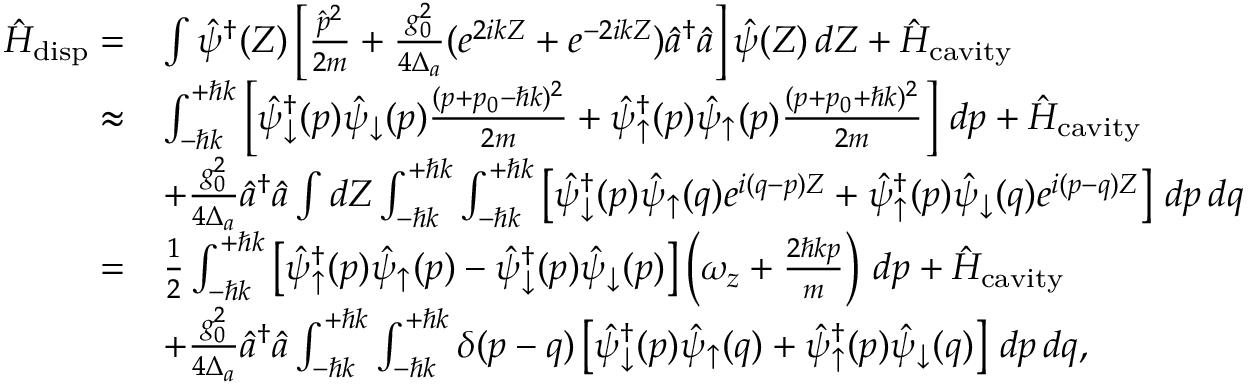<formula> <loc_0><loc_0><loc_500><loc_500>\begin{array} { r l } { \hat { H } _ { d i s p } = } & { \int \hat { \psi } ^ { \dagger } ( Z ) \left [ \frac { \hat { p } ^ { 2 } } { 2 m } + \frac { g _ { 0 } ^ { 2 } } { 4 \Delta _ { a } } ( e ^ { 2 i k Z } + e ^ { - 2 i k Z } ) \hat { a } ^ { \dagger } \hat { a } \right ] \hat { \psi } ( Z ) \, d Z + \hat { H } _ { c a v i t y } } \\ { \approx } & { \int _ { - \hbar { k } } ^ { + \hbar { k } } \left [ \hat { \psi } _ { \downarrow } ^ { \dagger } ( p ) \hat { \psi } _ { \downarrow } ( p ) \frac { ( p + p _ { 0 } - \hbar { k } ) ^ { 2 } } { 2 m } + \hat { \psi } _ { \uparrow } ^ { \dagger } ( p ) \hat { \psi } _ { \uparrow } ( p ) \frac { ( p + p _ { 0 } + \hbar { k } ) ^ { 2 } } { 2 m } \right ] \, d p + \hat { H } _ { c a v i t y } } \\ & { + \frac { g _ { 0 } ^ { 2 } } { 4 \Delta _ { a } } \hat { a } ^ { \dagger } \hat { a } \int d Z \int _ { - \hbar { k } } ^ { + \hbar { k } } \int _ { - \hbar { k } } ^ { + \hbar { k } } \left [ \hat { \psi } _ { \downarrow } ^ { \dagger } ( p ) \hat { \psi } _ { \uparrow } ( q ) e ^ { i ( q - p ) Z } + \hat { \psi } _ { \uparrow } ^ { \dagger } ( p ) \hat { \psi } _ { \downarrow } ( q ) e ^ { i ( p - q ) Z } \right ] \, d p \, d q } \\ { = } & { \frac { 1 } { 2 } \int _ { - \hbar { k } } ^ { + \hbar { k } } \left [ \hat { \psi } _ { \uparrow } ^ { \dagger } ( p ) \hat { \psi } _ { \uparrow } ( p ) - \hat { \psi } _ { \downarrow } ^ { \dagger } ( p ) \hat { \psi } _ { \downarrow } ( p ) \right ] \left ( \omega _ { z } + \frac { 2 \hbar { k } p } { m } \right ) \, d p + \hat { H } _ { c a v i t y } } \\ & { + \frac { g _ { 0 } ^ { 2 } } { 4 \Delta _ { a } } \hat { a } ^ { \dagger } \hat { a } \int _ { - \hbar { k } } ^ { + \hbar { k } } \int _ { - \hbar { k } } ^ { + \hbar { k } } \delta ( p - q ) \left [ \hat { \psi } _ { \downarrow } ^ { \dagger } ( p ) \hat { \psi } _ { \uparrow } ( q ) + \hat { \psi } _ { \uparrow } ^ { \dagger } ( p ) \hat { \psi } _ { \downarrow } ( q ) \right ] \, d p \, d q , } \end{array}</formula> 